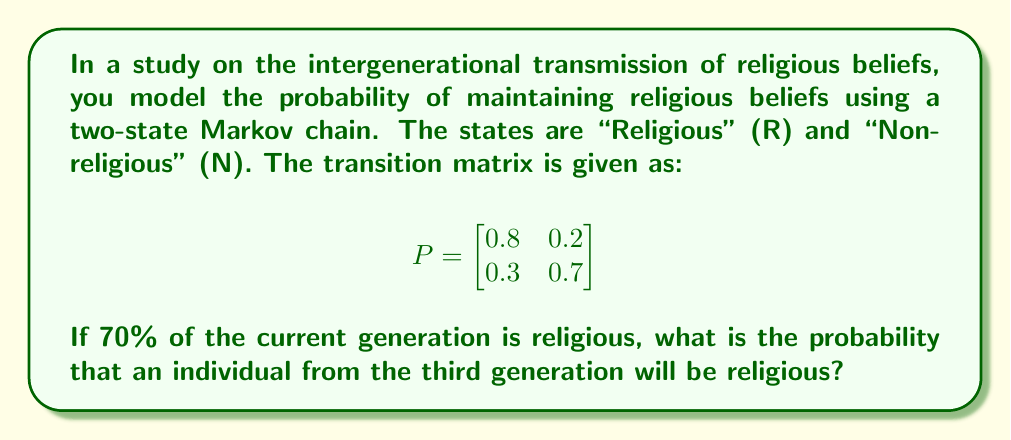Can you solve this math problem? To solve this problem, we'll follow these steps:

1) First, let's define the initial state vector. Given that 70% of the current generation is religious, we have:

   $$\pi_0 = \begin{bmatrix} 0.7 \\ 0.3 \end{bmatrix}$$

2) To find the state distribution after three generations, we need to multiply the initial state vector by the transition matrix three times:

   $$\pi_3 = \pi_0 P^3$$

3) Let's calculate $P^2$ first:

   $$P^2 = \begin{bmatrix}
   0.8 & 0.2 \\
   0.3 & 0.7
   \end{bmatrix} \times \begin{bmatrix}
   0.8 & 0.2 \\
   0.3 & 0.7
   \end{bmatrix} = \begin{bmatrix}
   0.70 & 0.30 \\
   0.39 & 0.61
   \end{bmatrix}$$

4) Now, let's calculate $P^3$:

   $$P^3 = P^2 \times P = \begin{bmatrix}
   0.70 & 0.30 \\
   0.39 & 0.61
   \end{bmatrix} \times \begin{bmatrix}
   0.8 & 0.2 \\
   0.3 & 0.7
   \end{bmatrix} = \begin{bmatrix}
   0.65 & 0.35 \\
   0.441 & 0.559
   \end{bmatrix}$$

5) Now we can calculate $\pi_3$:

   $$\pi_3 = \begin{bmatrix} 0.7 \\ 0.3 \end{bmatrix} \times \begin{bmatrix}
   0.65 & 0.35 \\
   0.441 & 0.559
   \end{bmatrix} = \begin{bmatrix} 0.5877 \\ 0.4123 \end{bmatrix}$$

6) The first element of $\pi_3$ represents the probability of being in the "Religious" state after three generations.

Therefore, the probability that an individual from the third generation will be religious is approximately 0.5877 or 58.77%.
Answer: 0.5877 